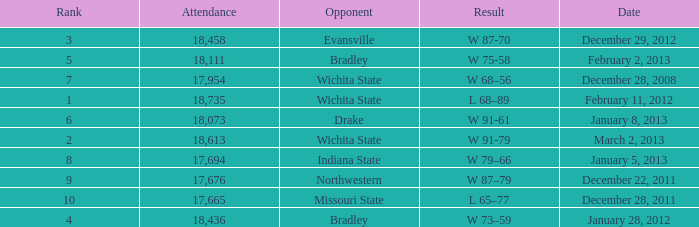Could you help me parse every detail presented in this table? {'header': ['Rank', 'Attendance', 'Opponent', 'Result', 'Date'], 'rows': [['3', '18,458', 'Evansville', 'W 87-70', 'December 29, 2012'], ['5', '18,111', 'Bradley', 'W 75-58', 'February 2, 2013'], ['7', '17,954', 'Wichita State', 'W 68–56', 'December 28, 2008'], ['1', '18,735', 'Wichita State', 'L 68–89', 'February 11, 2012'], ['6', '18,073', 'Drake', 'W 91-61', 'January 8, 2013'], ['2', '18,613', 'Wichita State', 'W 91-79', 'March 2, 2013'], ['8', '17,694', 'Indiana State', 'W 79–66', 'January 5, 2013'], ['9', '17,676', 'Northwestern', 'W 87–79', 'December 22, 2011'], ['10', '17,665', 'Missouri State', 'L 65–77', 'December 28, 2011'], ['4', '18,436', 'Bradley', 'W 73–59', 'January 28, 2012']]} What's the rank when attendance was less than 18,073 and having Northwestern as an opponent? 9.0. 